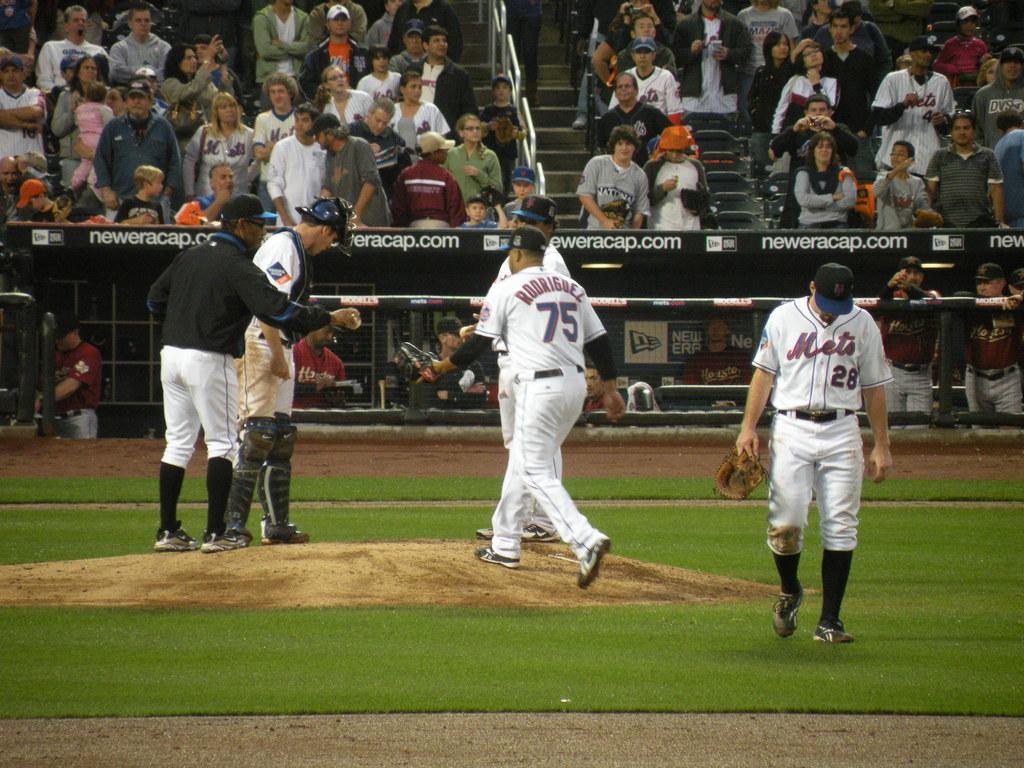Provide a one-sentence caption for the provided image. A group of Mets baseball player near the pitchers mound. 